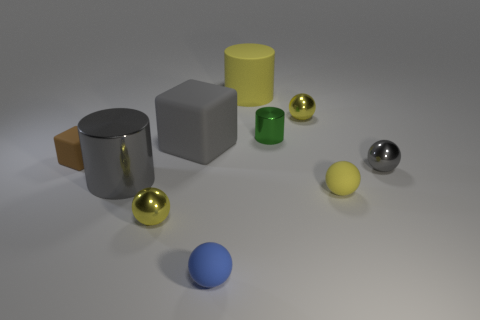Subtract all purple blocks. How many yellow spheres are left? 3 Subtract 1 spheres. How many spheres are left? 4 Subtract all blue balls. How many balls are left? 4 Subtract all small gray metal spheres. How many spheres are left? 4 Subtract all green spheres. Subtract all gray cubes. How many spheres are left? 5 Subtract all cylinders. How many objects are left? 7 Subtract 0 brown cylinders. How many objects are left? 10 Subtract all big yellow objects. Subtract all gray matte objects. How many objects are left? 8 Add 4 brown objects. How many brown objects are left? 5 Add 4 tiny blue things. How many tiny blue things exist? 5 